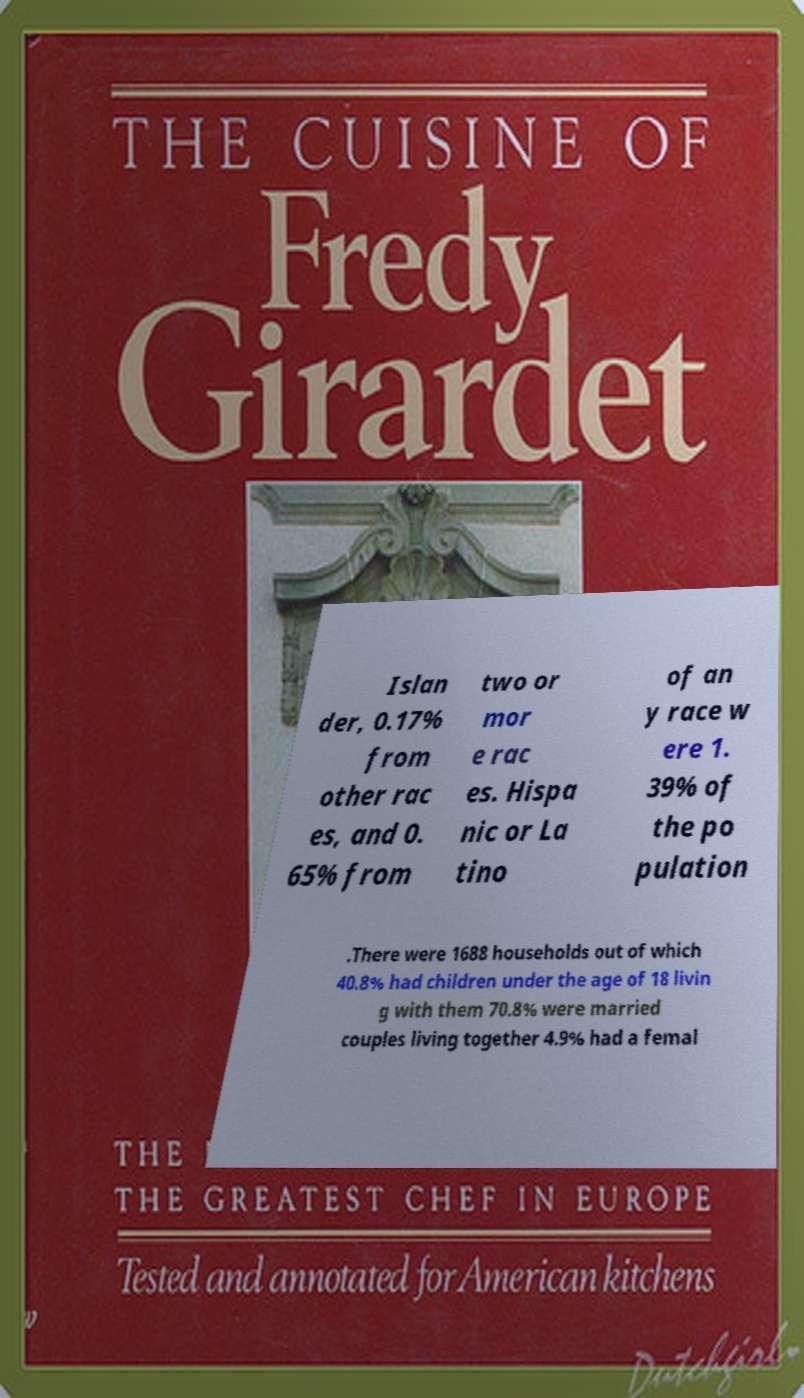Please identify and transcribe the text found in this image. Islan der, 0.17% from other rac es, and 0. 65% from two or mor e rac es. Hispa nic or La tino of an y race w ere 1. 39% of the po pulation .There were 1688 households out of which 40.8% had children under the age of 18 livin g with them 70.8% were married couples living together 4.9% had a femal 